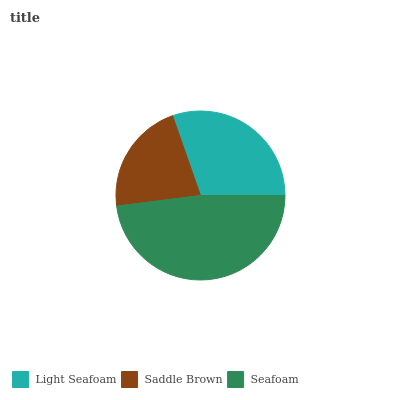Is Saddle Brown the minimum?
Answer yes or no. Yes. Is Seafoam the maximum?
Answer yes or no. Yes. Is Seafoam the minimum?
Answer yes or no. No. Is Saddle Brown the maximum?
Answer yes or no. No. Is Seafoam greater than Saddle Brown?
Answer yes or no. Yes. Is Saddle Brown less than Seafoam?
Answer yes or no. Yes. Is Saddle Brown greater than Seafoam?
Answer yes or no. No. Is Seafoam less than Saddle Brown?
Answer yes or no. No. Is Light Seafoam the high median?
Answer yes or no. Yes. Is Light Seafoam the low median?
Answer yes or no. Yes. Is Saddle Brown the high median?
Answer yes or no. No. Is Saddle Brown the low median?
Answer yes or no. No. 